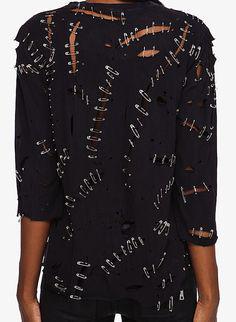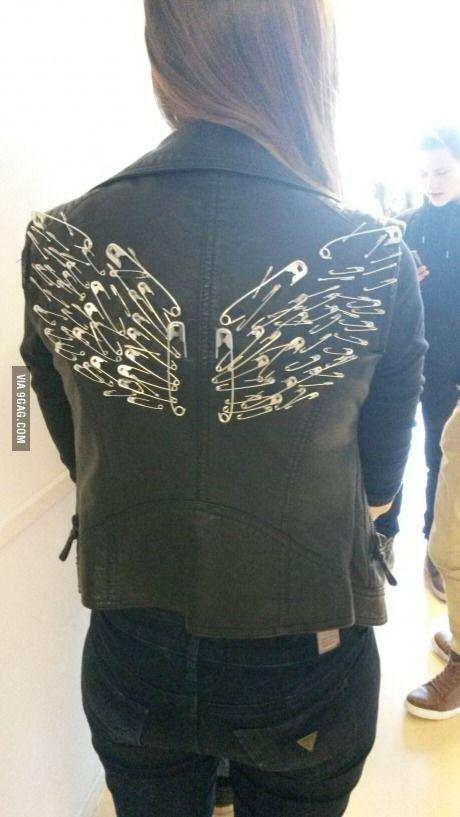The first image is the image on the left, the second image is the image on the right. Given the left and right images, does the statement "The images show the backs of coats." hold true? Answer yes or no. Yes. The first image is the image on the left, the second image is the image on the right. Evaluate the accuracy of this statement regarding the images: "At least one jacket is sleeveless.". Is it true? Answer yes or no. Yes. 